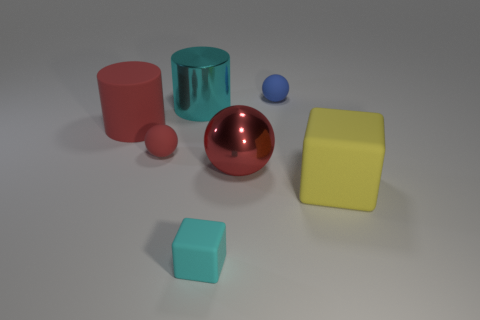Add 2 cyan matte objects. How many objects exist? 9 Subtract all cylinders. How many objects are left? 5 Add 2 yellow matte cubes. How many yellow matte cubes exist? 3 Subtract 0 gray balls. How many objects are left? 7 Subtract all cyan objects. Subtract all tiny matte cubes. How many objects are left? 4 Add 4 tiny cyan things. How many tiny cyan things are left? 5 